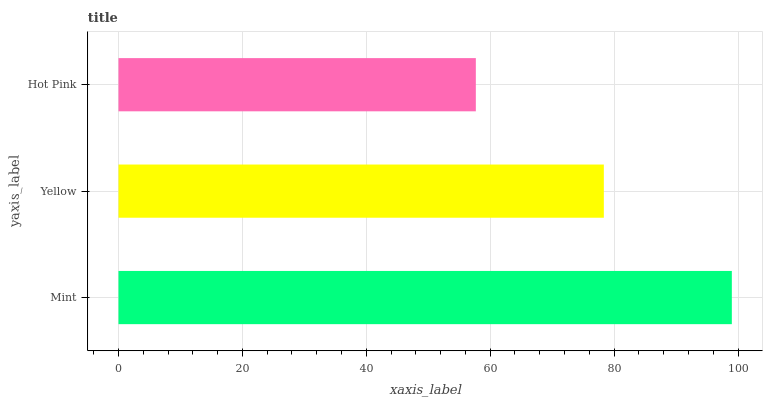Is Hot Pink the minimum?
Answer yes or no. Yes. Is Mint the maximum?
Answer yes or no. Yes. Is Yellow the minimum?
Answer yes or no. No. Is Yellow the maximum?
Answer yes or no. No. Is Mint greater than Yellow?
Answer yes or no. Yes. Is Yellow less than Mint?
Answer yes or no. Yes. Is Yellow greater than Mint?
Answer yes or no. No. Is Mint less than Yellow?
Answer yes or no. No. Is Yellow the high median?
Answer yes or no. Yes. Is Yellow the low median?
Answer yes or no. Yes. Is Mint the high median?
Answer yes or no. No. Is Hot Pink the low median?
Answer yes or no. No. 